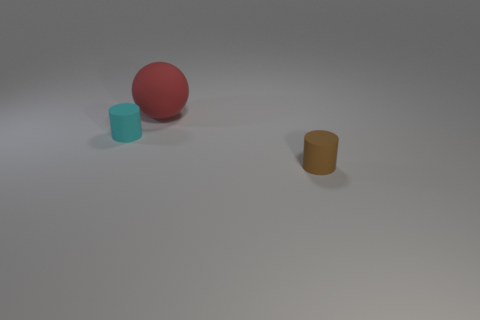Are any small blue metallic blocks visible? There are no blue metallic blocks visible; instead, there is a small blue cylindrical object and a red sphere, alongside a yellow-golden cylinder. 